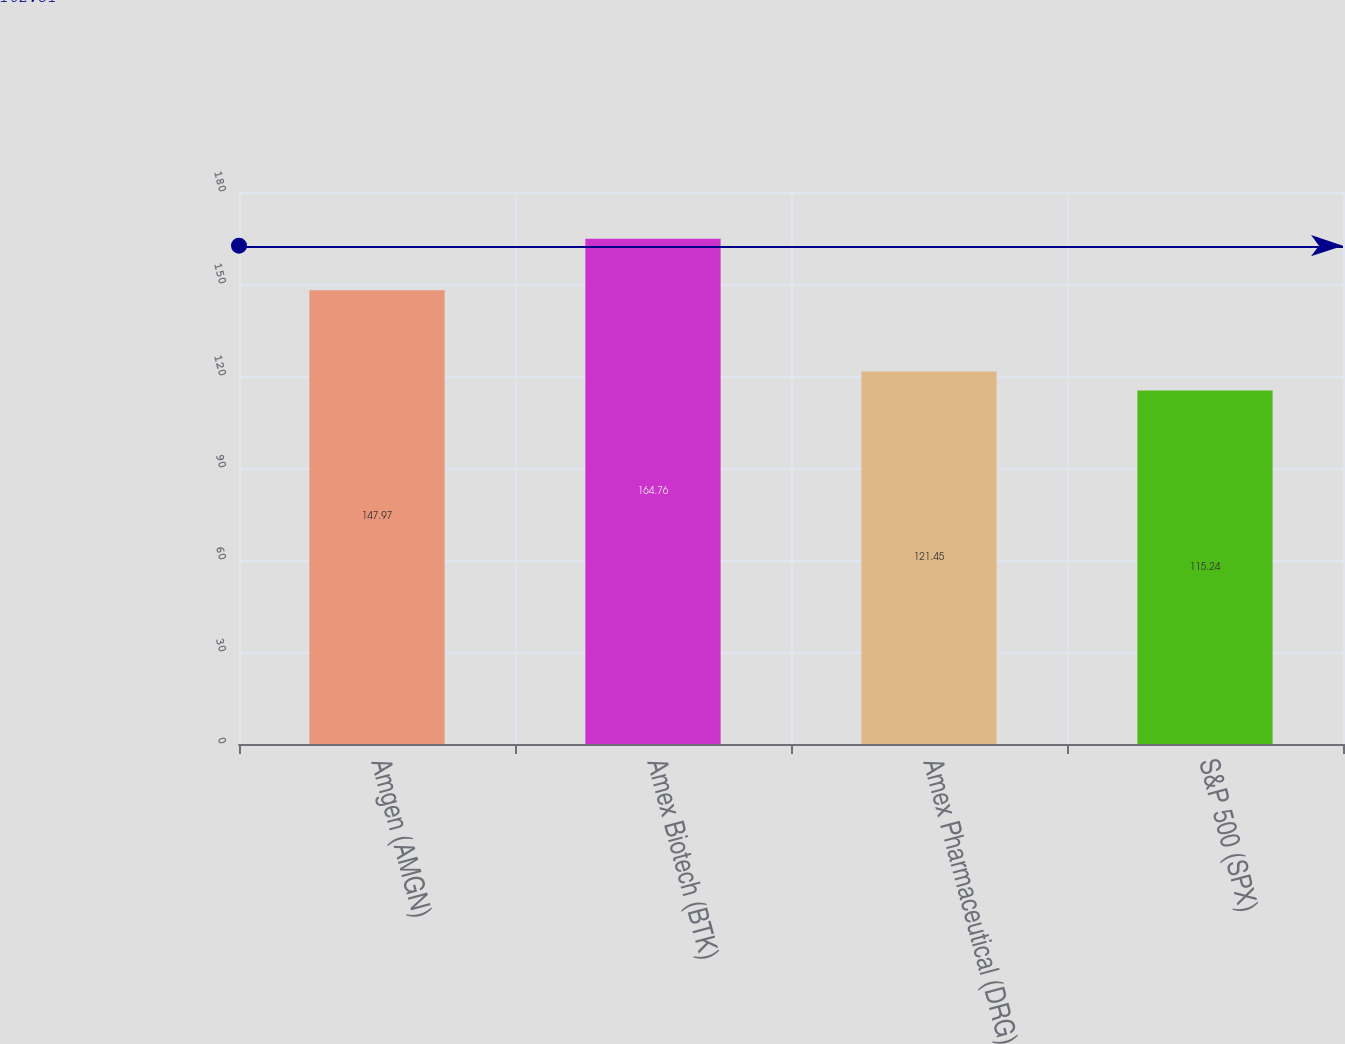Convert chart. <chart><loc_0><loc_0><loc_500><loc_500><bar_chart><fcel>Amgen (AMGN)<fcel>Amex Biotech (BTK)<fcel>Amex Pharmaceutical (DRG)<fcel>S&P 500 (SPX)<nl><fcel>147.97<fcel>164.76<fcel>121.45<fcel>115.24<nl></chart> 